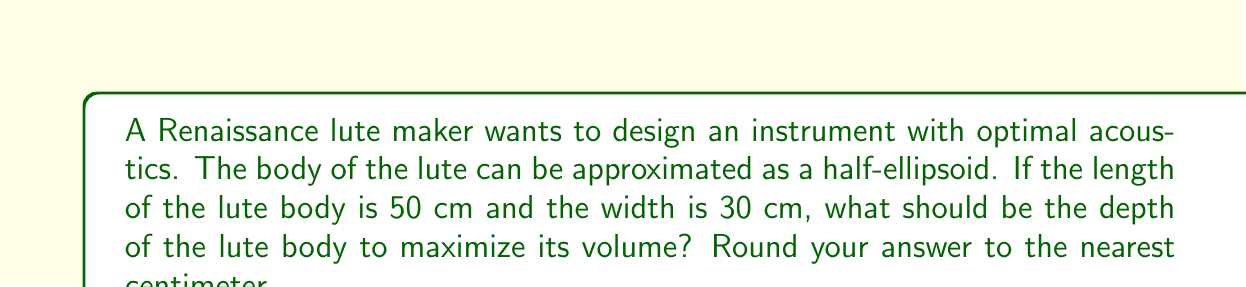Can you answer this question? To solve this problem, we need to use the formula for the volume of a half-ellipsoid and find its maximum value.

1. The volume of a half-ellipsoid is given by the formula:

   $$V = \frac{2}{3}\pi abc$$

   where $a$, $b$, and $c$ are the semi-axes of the ellipsoid.

2. In our case:
   $a = 25$ cm (half of the length)
   $b = 15$ cm (half of the width)
   $c$ = depth/2 (let's call the depth $d$)

3. Substituting these values into the volume formula:

   $$V = \frac{2}{3}\pi \cdot 25 \cdot 15 \cdot \frac{d}{2} = \frac{250\pi d}{2}$$

4. To find the maximum volume, we need to consider the constraint that the surface area of the half-ellipsoid remains constant. The surface area of a half-ellipsoid is approximated by:

   $$S \approx \pi ab + \frac{\pi}{2}(ac + bc)$$

5. Substituting our known values:

   $$S \approx \pi \cdot 25 \cdot 15 + \frac{\pi}{2}(25d + 15d) = 375\pi + 20\pi d$$

6. For optimal acoustics, we want to maximize the volume while keeping the surface area constant. This occurs when the depth is equal to the geometric mean of the length and width:

   $$d = \sqrt{2ab} = \sqrt{2 \cdot 50 \cdot 30} = \sqrt{3000} \approx 54.77$$

7. Rounding to the nearest centimeter, we get 55 cm.

This result is based on the principle that the geometric mean provides the optimal ratio for resonance in musical instruments.
Answer: 55 cm 